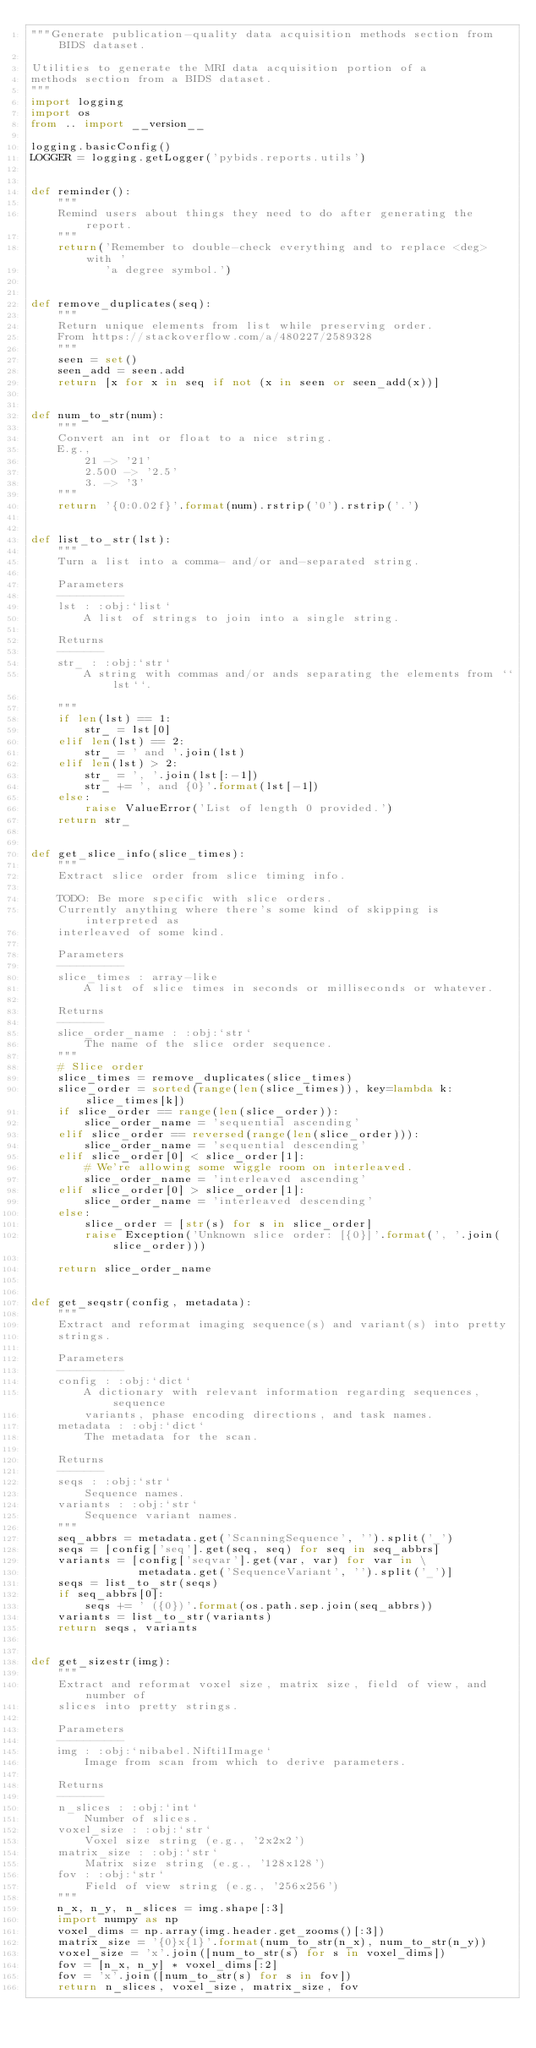<code> <loc_0><loc_0><loc_500><loc_500><_Python_>"""Generate publication-quality data acquisition methods section from BIDS dataset.

Utilities to generate the MRI data acquisition portion of a
methods section from a BIDS dataset.
"""
import logging
import os
from .. import __version__

logging.basicConfig()
LOGGER = logging.getLogger('pybids.reports.utils')


def reminder():
    """
    Remind users about things they need to do after generating the report.
    """
    return('Remember to double-check everything and to replace <deg> with '
           'a degree symbol.')


def remove_duplicates(seq):
    """
    Return unique elements from list while preserving order.
    From https://stackoverflow.com/a/480227/2589328
    """
    seen = set()
    seen_add = seen.add
    return [x for x in seq if not (x in seen or seen_add(x))]


def num_to_str(num):
    """
    Convert an int or float to a nice string.
    E.g.,
        21 -> '21'
        2.500 -> '2.5'
        3. -> '3'
    """
    return '{0:0.02f}'.format(num).rstrip('0').rstrip('.')


def list_to_str(lst):
    """
    Turn a list into a comma- and/or and-separated string.

    Parameters
    ----------
    lst : :obj:`list`
        A list of strings to join into a single string.

    Returns
    -------
    str_ : :obj:`str`
        A string with commas and/or ands separating the elements from ``lst``.

    """
    if len(lst) == 1:
        str_ = lst[0]
    elif len(lst) == 2:
        str_ = ' and '.join(lst)
    elif len(lst) > 2:
        str_ = ', '.join(lst[:-1])
        str_ += ', and {0}'.format(lst[-1])
    else:
        raise ValueError('List of length 0 provided.')
    return str_


def get_slice_info(slice_times):
    """
    Extract slice order from slice timing info.

    TODO: Be more specific with slice orders.
    Currently anything where there's some kind of skipping is interpreted as
    interleaved of some kind.

    Parameters
    ----------
    slice_times : array-like
        A list of slice times in seconds or milliseconds or whatever.

    Returns
    -------
    slice_order_name : :obj:`str`
        The name of the slice order sequence.
    """
    # Slice order
    slice_times = remove_duplicates(slice_times)
    slice_order = sorted(range(len(slice_times)), key=lambda k: slice_times[k])
    if slice_order == range(len(slice_order)):
        slice_order_name = 'sequential ascending'
    elif slice_order == reversed(range(len(slice_order))):
        slice_order_name = 'sequential descending'
    elif slice_order[0] < slice_order[1]:
        # We're allowing some wiggle room on interleaved.
        slice_order_name = 'interleaved ascending'
    elif slice_order[0] > slice_order[1]:
        slice_order_name = 'interleaved descending'
    else:
        slice_order = [str(s) for s in slice_order]
        raise Exception('Unknown slice order: [{0}]'.format(', '.join(slice_order)))

    return slice_order_name


def get_seqstr(config, metadata):
    """
    Extract and reformat imaging sequence(s) and variant(s) into pretty
    strings.

    Parameters
    ----------
    config : :obj:`dict`
        A dictionary with relevant information regarding sequences, sequence
        variants, phase encoding directions, and task names.
    metadata : :obj:`dict`
        The metadata for the scan.

    Returns
    -------
    seqs : :obj:`str`
        Sequence names.
    variants : :obj:`str`
        Sequence variant names.
    """
    seq_abbrs = metadata.get('ScanningSequence', '').split('_')
    seqs = [config['seq'].get(seq, seq) for seq in seq_abbrs]
    variants = [config['seqvar'].get(var, var) for var in \
                metadata.get('SequenceVariant', '').split('_')]
    seqs = list_to_str(seqs)
    if seq_abbrs[0]:
        seqs += ' ({0})'.format(os.path.sep.join(seq_abbrs))
    variants = list_to_str(variants)
    return seqs, variants


def get_sizestr(img):
    """
    Extract and reformat voxel size, matrix size, field of view, and number of
    slices into pretty strings.

    Parameters
    ----------
    img : :obj:`nibabel.Nifti1Image`
        Image from scan from which to derive parameters.

    Returns
    -------
    n_slices : :obj:`int`
        Number of slices.
    voxel_size : :obj:`str`
        Voxel size string (e.g., '2x2x2')
    matrix_size : :obj:`str`
        Matrix size string (e.g., '128x128')
    fov : :obj:`str`
        Field of view string (e.g., '256x256')
    """
    n_x, n_y, n_slices = img.shape[:3]
    import numpy as np
    voxel_dims = np.array(img.header.get_zooms()[:3])
    matrix_size = '{0}x{1}'.format(num_to_str(n_x), num_to_str(n_y))
    voxel_size = 'x'.join([num_to_str(s) for s in voxel_dims])
    fov = [n_x, n_y] * voxel_dims[:2]
    fov = 'x'.join([num_to_str(s) for s in fov])
    return n_slices, voxel_size, matrix_size, fov
</code> 